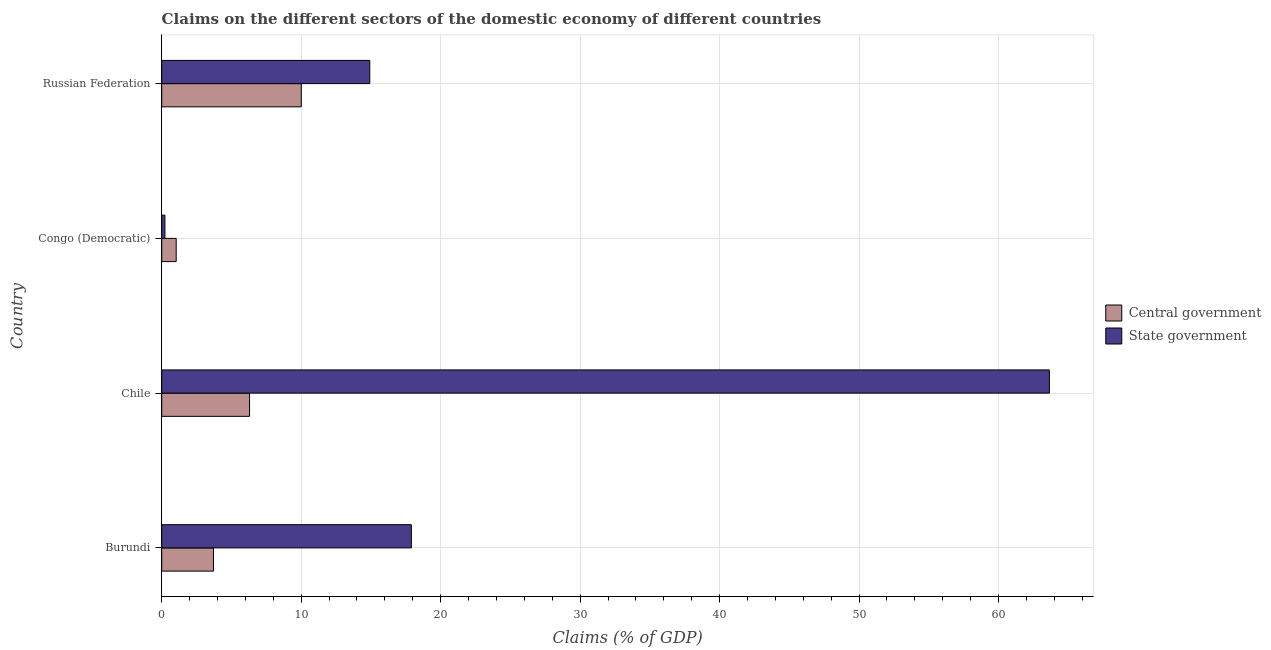How many groups of bars are there?
Offer a very short reply. 4. How many bars are there on the 3rd tick from the top?
Provide a short and direct response. 2. How many bars are there on the 2nd tick from the bottom?
Provide a short and direct response. 2. What is the label of the 3rd group of bars from the top?
Provide a succinct answer. Chile. In how many cases, is the number of bars for a given country not equal to the number of legend labels?
Ensure brevity in your answer.  0. What is the claims on central government in Congo (Democratic)?
Provide a short and direct response. 1.04. Across all countries, what is the maximum claims on state government?
Provide a short and direct response. 63.64. Across all countries, what is the minimum claims on central government?
Provide a succinct answer. 1.04. In which country was the claims on central government minimum?
Offer a very short reply. Congo (Democratic). What is the total claims on state government in the graph?
Provide a short and direct response. 96.69. What is the difference between the claims on state government in Chile and that in Congo (Democratic)?
Provide a succinct answer. 63.41. What is the difference between the claims on central government in Russian Federation and the claims on state government in Congo (Democratic)?
Your answer should be very brief. 9.78. What is the average claims on central government per country?
Offer a very short reply. 5.26. What is the difference between the claims on state government and claims on central government in Congo (Democratic)?
Your answer should be very brief. -0.81. In how many countries, is the claims on state government greater than 2 %?
Offer a very short reply. 3. What is the ratio of the claims on state government in Congo (Democratic) to that in Russian Federation?
Your answer should be very brief. 0.01. Is the difference between the claims on central government in Congo (Democratic) and Russian Federation greater than the difference between the claims on state government in Congo (Democratic) and Russian Federation?
Your response must be concise. Yes. What is the difference between the highest and the second highest claims on central government?
Provide a short and direct response. 3.71. What is the difference between the highest and the lowest claims on central government?
Make the answer very short. 8.97. Is the sum of the claims on central government in Burundi and Chile greater than the maximum claims on state government across all countries?
Keep it short and to the point. No. What does the 1st bar from the top in Chile represents?
Your answer should be very brief. State government. What does the 2nd bar from the bottom in Congo (Democratic) represents?
Make the answer very short. State government. Are all the bars in the graph horizontal?
Offer a terse response. Yes. What is the difference between two consecutive major ticks on the X-axis?
Make the answer very short. 10. Are the values on the major ticks of X-axis written in scientific E-notation?
Provide a short and direct response. No. Does the graph contain grids?
Make the answer very short. Yes. How are the legend labels stacked?
Provide a succinct answer. Vertical. What is the title of the graph?
Keep it short and to the point. Claims on the different sectors of the domestic economy of different countries. Does "Constant 2005 US$" appear as one of the legend labels in the graph?
Keep it short and to the point. No. What is the label or title of the X-axis?
Your response must be concise. Claims (% of GDP). What is the Claims (% of GDP) in Central government in Burundi?
Your response must be concise. 3.71. What is the Claims (% of GDP) in State government in Burundi?
Your response must be concise. 17.9. What is the Claims (% of GDP) of Central government in Chile?
Keep it short and to the point. 6.3. What is the Claims (% of GDP) in State government in Chile?
Make the answer very short. 63.64. What is the Claims (% of GDP) of Central government in Congo (Democratic)?
Give a very brief answer. 1.04. What is the Claims (% of GDP) in State government in Congo (Democratic)?
Keep it short and to the point. 0.23. What is the Claims (% of GDP) of Central government in Russian Federation?
Make the answer very short. 10.01. What is the Claims (% of GDP) of State government in Russian Federation?
Offer a very short reply. 14.92. Across all countries, what is the maximum Claims (% of GDP) of Central government?
Offer a very short reply. 10.01. Across all countries, what is the maximum Claims (% of GDP) of State government?
Your answer should be compact. 63.64. Across all countries, what is the minimum Claims (% of GDP) of Central government?
Offer a terse response. 1.04. Across all countries, what is the minimum Claims (% of GDP) in State government?
Provide a succinct answer. 0.23. What is the total Claims (% of GDP) in Central government in the graph?
Provide a short and direct response. 21.06. What is the total Claims (% of GDP) of State government in the graph?
Make the answer very short. 96.69. What is the difference between the Claims (% of GDP) in Central government in Burundi and that in Chile?
Offer a very short reply. -2.59. What is the difference between the Claims (% of GDP) in State government in Burundi and that in Chile?
Offer a terse response. -45.74. What is the difference between the Claims (% of GDP) of Central government in Burundi and that in Congo (Democratic)?
Offer a terse response. 2.67. What is the difference between the Claims (% of GDP) in State government in Burundi and that in Congo (Democratic)?
Ensure brevity in your answer.  17.67. What is the difference between the Claims (% of GDP) of Central government in Burundi and that in Russian Federation?
Your answer should be very brief. -6.3. What is the difference between the Claims (% of GDP) in State government in Burundi and that in Russian Federation?
Offer a terse response. 2.98. What is the difference between the Claims (% of GDP) of Central government in Chile and that in Congo (Democratic)?
Your response must be concise. 5.26. What is the difference between the Claims (% of GDP) of State government in Chile and that in Congo (Democratic)?
Ensure brevity in your answer.  63.41. What is the difference between the Claims (% of GDP) in Central government in Chile and that in Russian Federation?
Provide a short and direct response. -3.71. What is the difference between the Claims (% of GDP) of State government in Chile and that in Russian Federation?
Provide a succinct answer. 48.73. What is the difference between the Claims (% of GDP) of Central government in Congo (Democratic) and that in Russian Federation?
Your answer should be compact. -8.97. What is the difference between the Claims (% of GDP) of State government in Congo (Democratic) and that in Russian Federation?
Provide a short and direct response. -14.69. What is the difference between the Claims (% of GDP) in Central government in Burundi and the Claims (% of GDP) in State government in Chile?
Your response must be concise. -59.93. What is the difference between the Claims (% of GDP) of Central government in Burundi and the Claims (% of GDP) of State government in Congo (Democratic)?
Your answer should be very brief. 3.48. What is the difference between the Claims (% of GDP) of Central government in Burundi and the Claims (% of GDP) of State government in Russian Federation?
Provide a succinct answer. -11.21. What is the difference between the Claims (% of GDP) in Central government in Chile and the Claims (% of GDP) in State government in Congo (Democratic)?
Your response must be concise. 6.07. What is the difference between the Claims (% of GDP) of Central government in Chile and the Claims (% of GDP) of State government in Russian Federation?
Keep it short and to the point. -8.62. What is the difference between the Claims (% of GDP) of Central government in Congo (Democratic) and the Claims (% of GDP) of State government in Russian Federation?
Offer a terse response. -13.88. What is the average Claims (% of GDP) in Central government per country?
Your answer should be very brief. 5.26. What is the average Claims (% of GDP) in State government per country?
Ensure brevity in your answer.  24.17. What is the difference between the Claims (% of GDP) in Central government and Claims (% of GDP) in State government in Burundi?
Your answer should be compact. -14.19. What is the difference between the Claims (% of GDP) of Central government and Claims (% of GDP) of State government in Chile?
Offer a very short reply. -57.34. What is the difference between the Claims (% of GDP) of Central government and Claims (% of GDP) of State government in Congo (Democratic)?
Your answer should be compact. 0.81. What is the difference between the Claims (% of GDP) of Central government and Claims (% of GDP) of State government in Russian Federation?
Your response must be concise. -4.91. What is the ratio of the Claims (% of GDP) in Central government in Burundi to that in Chile?
Make the answer very short. 0.59. What is the ratio of the Claims (% of GDP) in State government in Burundi to that in Chile?
Offer a terse response. 0.28. What is the ratio of the Claims (% of GDP) of Central government in Burundi to that in Congo (Democratic)?
Your answer should be compact. 3.58. What is the ratio of the Claims (% of GDP) in State government in Burundi to that in Congo (Democratic)?
Provide a succinct answer. 77.73. What is the ratio of the Claims (% of GDP) in Central government in Burundi to that in Russian Federation?
Ensure brevity in your answer.  0.37. What is the ratio of the Claims (% of GDP) of State government in Burundi to that in Russian Federation?
Make the answer very short. 1.2. What is the ratio of the Claims (% of GDP) of Central government in Chile to that in Congo (Democratic)?
Your answer should be very brief. 6.07. What is the ratio of the Claims (% of GDP) in State government in Chile to that in Congo (Democratic)?
Ensure brevity in your answer.  276.37. What is the ratio of the Claims (% of GDP) of Central government in Chile to that in Russian Federation?
Ensure brevity in your answer.  0.63. What is the ratio of the Claims (% of GDP) of State government in Chile to that in Russian Federation?
Give a very brief answer. 4.27. What is the ratio of the Claims (% of GDP) in Central government in Congo (Democratic) to that in Russian Federation?
Your answer should be very brief. 0.1. What is the ratio of the Claims (% of GDP) in State government in Congo (Democratic) to that in Russian Federation?
Ensure brevity in your answer.  0.02. What is the difference between the highest and the second highest Claims (% of GDP) in Central government?
Give a very brief answer. 3.71. What is the difference between the highest and the second highest Claims (% of GDP) in State government?
Your answer should be compact. 45.74. What is the difference between the highest and the lowest Claims (% of GDP) of Central government?
Offer a very short reply. 8.97. What is the difference between the highest and the lowest Claims (% of GDP) of State government?
Offer a terse response. 63.41. 